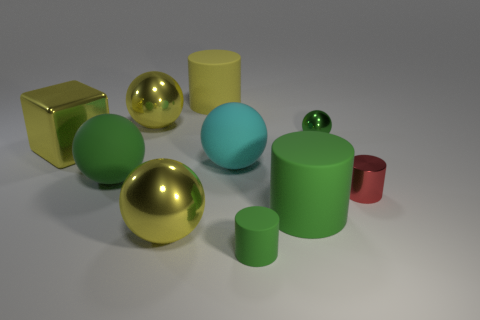Subtract all cyan spheres. How many spheres are left? 4 Subtract 1 cylinders. How many cylinders are left? 3 Subtract all tiny spheres. How many spheres are left? 4 Subtract all gray balls. Subtract all green cylinders. How many balls are left? 5 Subtract all cylinders. How many objects are left? 6 Add 4 red metal objects. How many red metal objects are left? 5 Add 8 green rubber cylinders. How many green rubber cylinders exist? 10 Subtract 0 brown cylinders. How many objects are left? 10 Subtract all gray metal cylinders. Subtract all big green things. How many objects are left? 8 